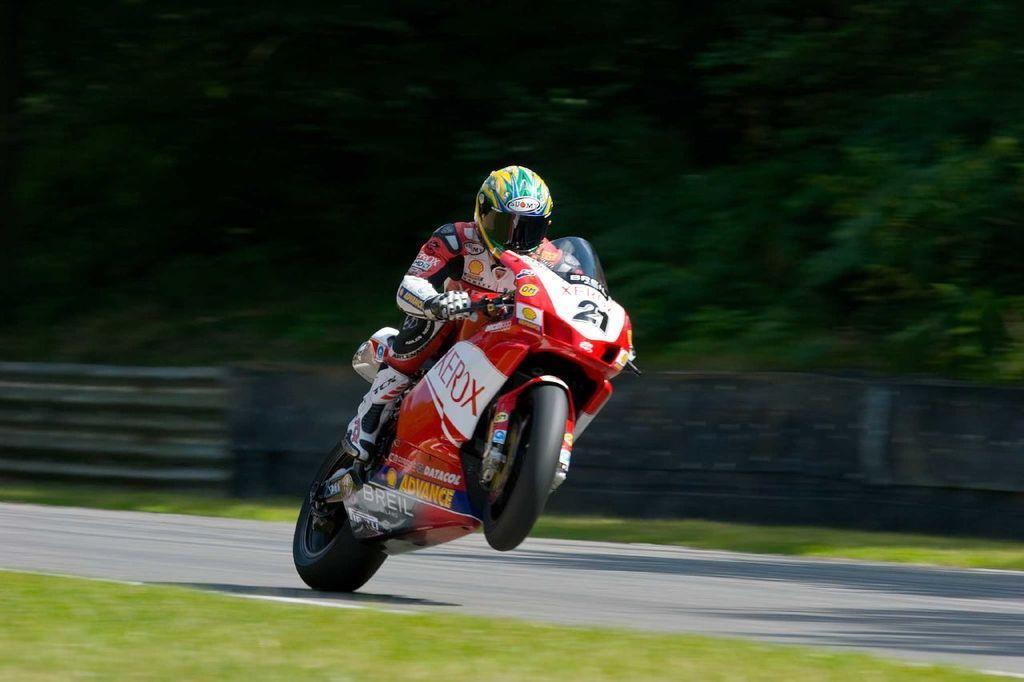Can you describe this image briefly? In this picture, we see the person who is wearing the yellow and the green helmet is riding the bike. At the bottom, we see the grass and the road. Behind him, we see the road railing. There are trees in the background. This picture is blurred in the background. 